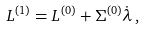Convert formula to latex. <formula><loc_0><loc_0><loc_500><loc_500>L ^ { ( 1 ) } = L ^ { ( 0 ) } + \Sigma ^ { ( 0 ) } \dot { \lambda } \, ,</formula> 